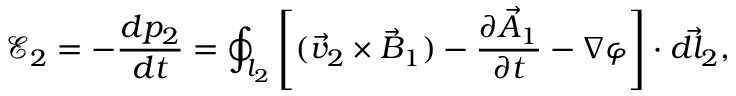Convert formula to latex. <formula><loc_0><loc_0><loc_500><loc_500>\mathcal { E } _ { 2 } = - \frac { d p _ { 2 } } { d t } = \oint _ { l _ { 2 } } \left [ ( \vec { v } _ { 2 } \times \vec { B } _ { 1 } ) - \frac { \partial \vec { A } _ { 1 } } { \partial t } - \nabla \varphi \right ] \cdot \vec { d l _ { 2 } } ,</formula> 